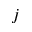<formula> <loc_0><loc_0><loc_500><loc_500>j</formula> 